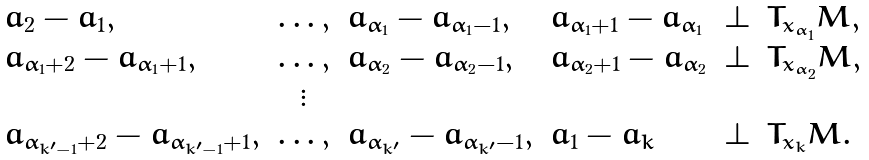<formula> <loc_0><loc_0><loc_500><loc_500>\begin{array} { l c l l l l } a _ { 2 } - a _ { 1 } , & \dots , & a _ { \alpha _ { 1 } } - a _ { \alpha _ { 1 } - 1 } , & a _ { \alpha _ { 1 } + 1 } - a _ { \alpha _ { 1 } } & \perp & T _ { x _ { \alpha _ { 1 } } } M , \\ a _ { \alpha _ { 1 } + 2 } - a _ { \alpha _ { 1 } + 1 } , & \dots , & a _ { \alpha _ { 2 } } - a _ { \alpha _ { 2 } - 1 } , & a _ { \alpha _ { 2 } + 1 } - a _ { \alpha _ { 2 } } & \perp & T _ { x _ { \alpha _ { 2 } } } M , \\ & \vdots \\ a _ { \alpha _ { k ^ { \prime } - 1 } + 2 } - a _ { \alpha _ { k ^ { \prime } - 1 } + 1 } , & \dots , & a _ { \alpha _ { k ^ { \prime } } } - a _ { \alpha _ { k ^ { \prime } } - 1 } , & a _ { 1 } - a _ { k } & \perp & T _ { x _ { k } } M . \end{array}</formula> 